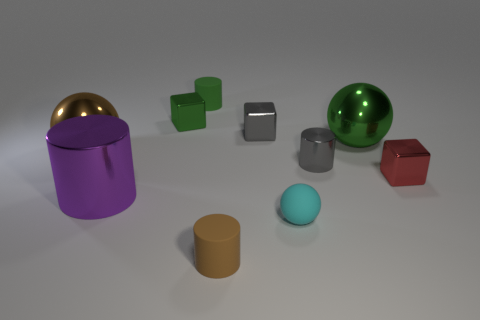There is a gray cylinder that is the same size as the cyan matte ball; what material is it? The gray cylinder appears to have a metallic sheen, which suggests that it is likely made of metal. Its reflective surface is a characteristic commonly associated with metal objects. 